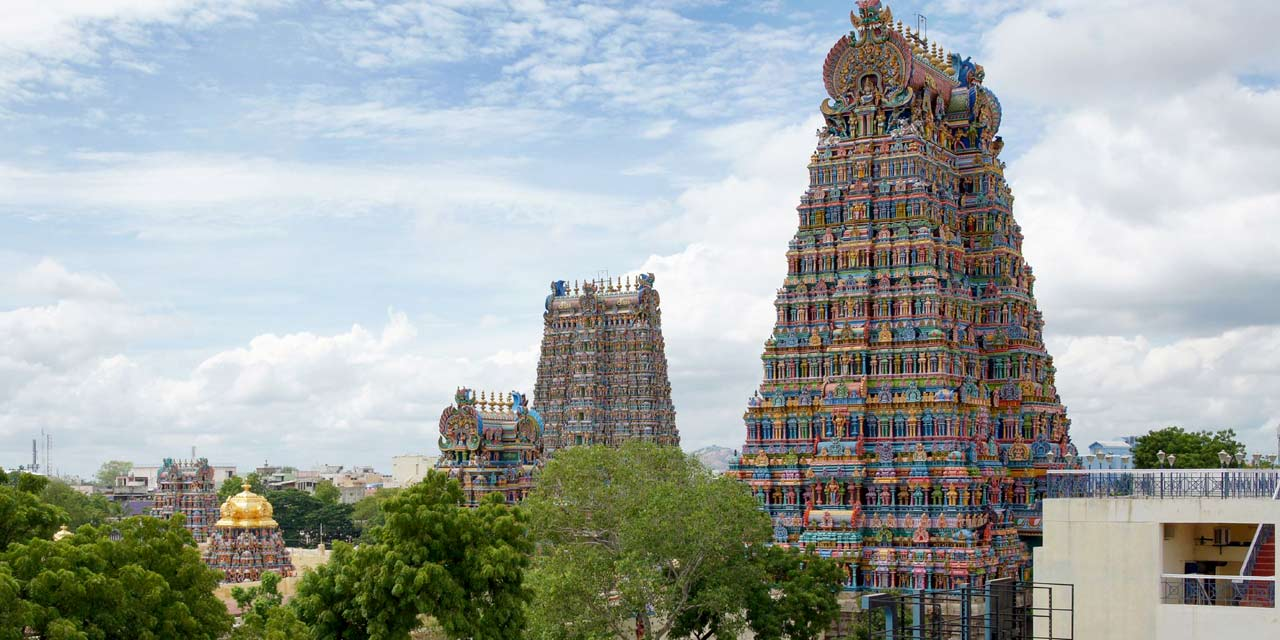Describe a short realistic scenario of someone visiting this temple. A middle-aged woman, clad in a simple sari, enters the Meenakshi Amman Temple early in the morning. As she walks through the grand entrance, she pauses to take in the vibrant colors and intricate sculptures adorning the gopurams. She joins the queue of devotees, her hands folded in prayer, and slowly makes her way to the main shrine. Offering a small garland to the priest, she closes her eyes and silently prays, seeking blessings for her family. After her prayers, she sits for a moment in the hall, absorbing the serene atmosphere before heading out with a sense of peace and spiritual fulfillment.  Describe a long realistic scenario of a day-long event at the temple. It's the day of the vibrant Meenakshi Thirukalyanam festival, celebrating the divine marriage of Meenakshi and Sundareswarar. The temple is abuzz with activity right from the early hours. Devotees throng the entrance, dressed in their finest traditional attire, children excited while elders chant hymns. The air is thick with the scent of flowers, incense, and offerings. The main event, the symbolic wedding ceremony, is held in the elaborately decorated mandapam inside the temple. Priests perform rituals amidst Vedic chants while the crowd watches with rapt devotion. Outside, cultural performances, dance, and music fill the temple grounds. Stalls offering traditional food and crafts line the pathways, turning the temple into a lively fairground. As night falls, the temple is illuminated with oil lamps, transforming it into a celestial paradise. The day ends with a grand procession, the deities carried through the streets, accompanied by drummers and musicians. The energy, devotion, and sheer color of the day leave the attendees spiritually enriched and immensely joyous. 